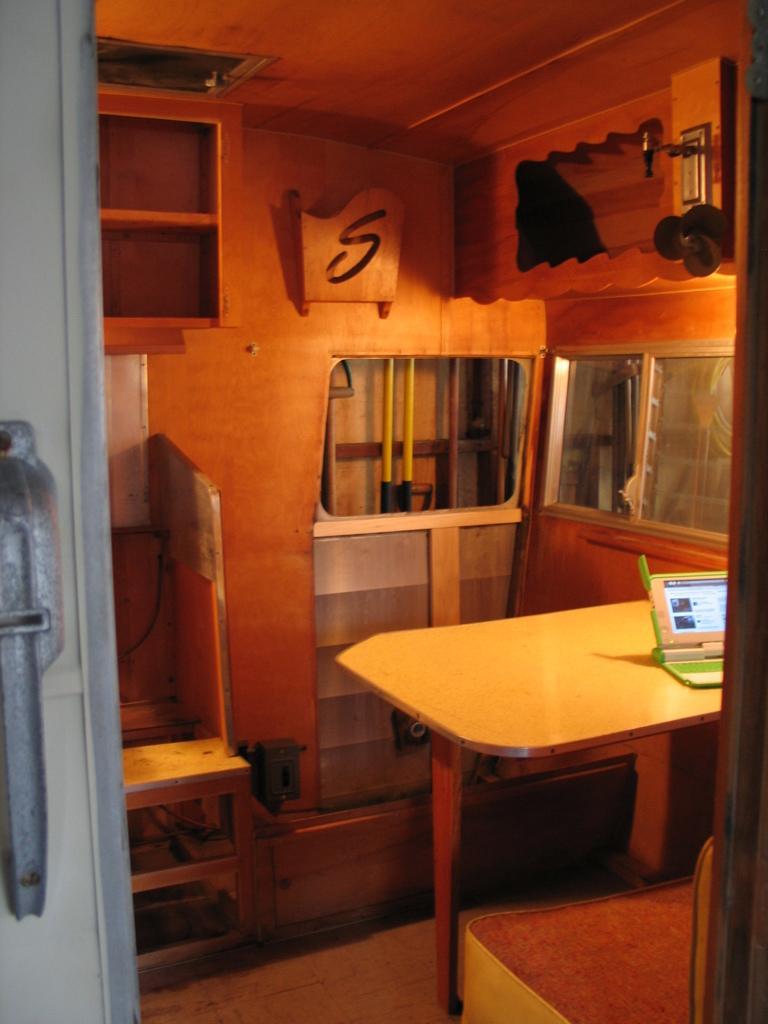Please provide a concise description of this image. In the image there is a table, chair and in front of the table there is a seat, on the table there is a laptop and there are some other objects behind the table. 